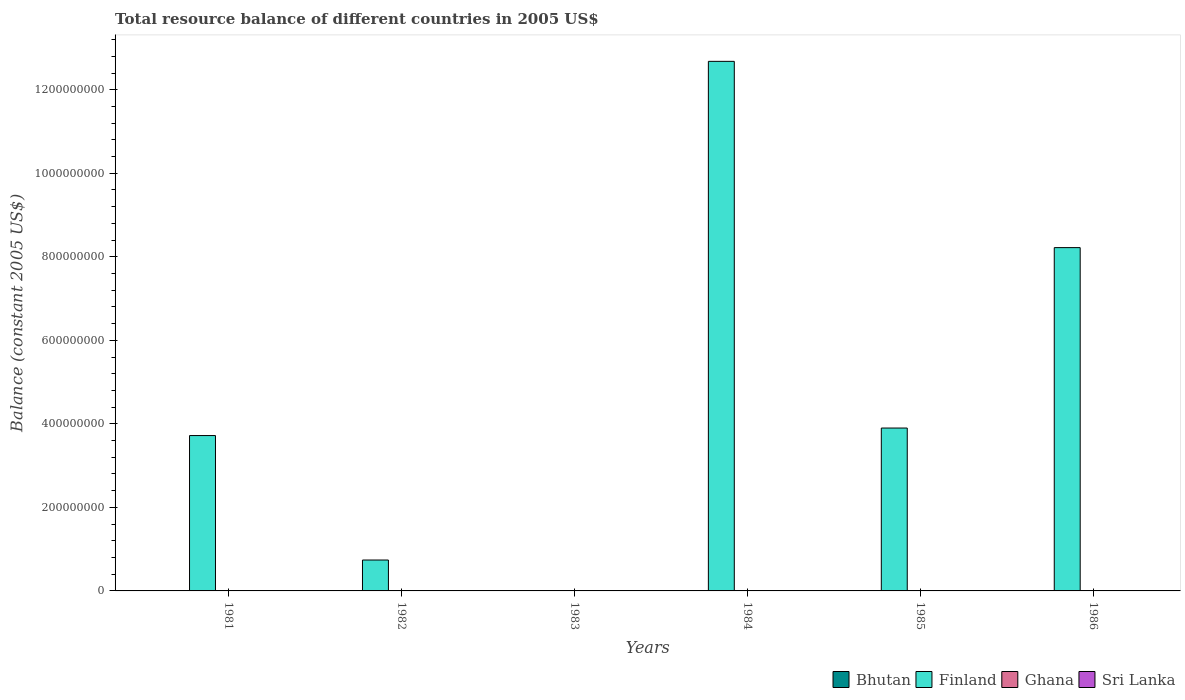Are the number of bars per tick equal to the number of legend labels?
Your response must be concise. No. Are the number of bars on each tick of the X-axis equal?
Make the answer very short. No. How many bars are there on the 4th tick from the right?
Make the answer very short. 0. In how many cases, is the number of bars for a given year not equal to the number of legend labels?
Provide a succinct answer. 6. Across all years, what is the maximum total resource balance in Finland?
Offer a terse response. 1.27e+09. Across all years, what is the minimum total resource balance in Ghana?
Offer a very short reply. 0. What is the total total resource balance in Sri Lanka in the graph?
Provide a succinct answer. 0. What is the difference between the total resource balance in Finland in 1982 and the total resource balance in Bhutan in 1985?
Offer a very short reply. 7.40e+07. What is the average total resource balance in Ghana per year?
Offer a very short reply. 5133.33. In the year 1982, what is the difference between the total resource balance in Ghana and total resource balance in Finland?
Provide a short and direct response. -7.40e+07. What is the difference between the highest and the second highest total resource balance in Finland?
Provide a short and direct response. 4.46e+08. What is the difference between the highest and the lowest total resource balance in Finland?
Offer a very short reply. 1.27e+09. Is it the case that in every year, the sum of the total resource balance in Bhutan and total resource balance in Finland is greater than the sum of total resource balance in Sri Lanka and total resource balance in Ghana?
Your answer should be very brief. No. Is it the case that in every year, the sum of the total resource balance in Finland and total resource balance in Ghana is greater than the total resource balance in Bhutan?
Provide a succinct answer. No. How many bars are there?
Give a very brief answer. 6. Are all the bars in the graph horizontal?
Provide a short and direct response. No. Are the values on the major ticks of Y-axis written in scientific E-notation?
Provide a short and direct response. No. Does the graph contain any zero values?
Offer a terse response. Yes. Does the graph contain grids?
Your response must be concise. No. Where does the legend appear in the graph?
Give a very brief answer. Bottom right. How many legend labels are there?
Keep it short and to the point. 4. How are the legend labels stacked?
Provide a short and direct response. Horizontal. What is the title of the graph?
Your answer should be very brief. Total resource balance of different countries in 2005 US$. Does "Gambia, The" appear as one of the legend labels in the graph?
Provide a short and direct response. No. What is the label or title of the X-axis?
Give a very brief answer. Years. What is the label or title of the Y-axis?
Your answer should be compact. Balance (constant 2005 US$). What is the Balance (constant 2005 US$) in Finland in 1981?
Your answer should be very brief. 3.72e+08. What is the Balance (constant 2005 US$) of Bhutan in 1982?
Offer a terse response. 0. What is the Balance (constant 2005 US$) of Finland in 1982?
Provide a succinct answer. 7.40e+07. What is the Balance (constant 2005 US$) in Ghana in 1982?
Ensure brevity in your answer.  3.08e+04. What is the Balance (constant 2005 US$) in Sri Lanka in 1982?
Make the answer very short. 0. What is the Balance (constant 2005 US$) of Bhutan in 1983?
Your answer should be very brief. 0. What is the Balance (constant 2005 US$) of Sri Lanka in 1983?
Ensure brevity in your answer.  0. What is the Balance (constant 2005 US$) in Finland in 1984?
Your answer should be compact. 1.27e+09. What is the Balance (constant 2005 US$) in Sri Lanka in 1984?
Your answer should be compact. 0. What is the Balance (constant 2005 US$) of Finland in 1985?
Provide a short and direct response. 3.90e+08. What is the Balance (constant 2005 US$) in Ghana in 1985?
Your answer should be very brief. 0. What is the Balance (constant 2005 US$) in Sri Lanka in 1985?
Give a very brief answer. 0. What is the Balance (constant 2005 US$) of Finland in 1986?
Keep it short and to the point. 8.22e+08. Across all years, what is the maximum Balance (constant 2005 US$) in Finland?
Provide a succinct answer. 1.27e+09. Across all years, what is the maximum Balance (constant 2005 US$) of Ghana?
Keep it short and to the point. 3.08e+04. What is the total Balance (constant 2005 US$) in Finland in the graph?
Your response must be concise. 2.93e+09. What is the total Balance (constant 2005 US$) of Ghana in the graph?
Provide a short and direct response. 3.08e+04. What is the difference between the Balance (constant 2005 US$) in Finland in 1981 and that in 1982?
Give a very brief answer. 2.98e+08. What is the difference between the Balance (constant 2005 US$) in Finland in 1981 and that in 1984?
Keep it short and to the point. -8.96e+08. What is the difference between the Balance (constant 2005 US$) in Finland in 1981 and that in 1985?
Ensure brevity in your answer.  -1.80e+07. What is the difference between the Balance (constant 2005 US$) in Finland in 1981 and that in 1986?
Your answer should be compact. -4.50e+08. What is the difference between the Balance (constant 2005 US$) of Finland in 1982 and that in 1984?
Your answer should be very brief. -1.19e+09. What is the difference between the Balance (constant 2005 US$) of Finland in 1982 and that in 1985?
Your answer should be compact. -3.16e+08. What is the difference between the Balance (constant 2005 US$) in Finland in 1982 and that in 1986?
Your response must be concise. -7.48e+08. What is the difference between the Balance (constant 2005 US$) of Finland in 1984 and that in 1985?
Your answer should be very brief. 8.78e+08. What is the difference between the Balance (constant 2005 US$) in Finland in 1984 and that in 1986?
Make the answer very short. 4.46e+08. What is the difference between the Balance (constant 2005 US$) in Finland in 1985 and that in 1986?
Your answer should be compact. -4.32e+08. What is the difference between the Balance (constant 2005 US$) of Finland in 1981 and the Balance (constant 2005 US$) of Ghana in 1982?
Give a very brief answer. 3.72e+08. What is the average Balance (constant 2005 US$) in Bhutan per year?
Provide a succinct answer. 0. What is the average Balance (constant 2005 US$) of Finland per year?
Ensure brevity in your answer.  4.88e+08. What is the average Balance (constant 2005 US$) of Ghana per year?
Provide a short and direct response. 5133.33. What is the average Balance (constant 2005 US$) in Sri Lanka per year?
Provide a succinct answer. 0. In the year 1982, what is the difference between the Balance (constant 2005 US$) of Finland and Balance (constant 2005 US$) of Ghana?
Provide a short and direct response. 7.40e+07. What is the ratio of the Balance (constant 2005 US$) of Finland in 1981 to that in 1982?
Keep it short and to the point. 5.03. What is the ratio of the Balance (constant 2005 US$) of Finland in 1981 to that in 1984?
Provide a succinct answer. 0.29. What is the ratio of the Balance (constant 2005 US$) of Finland in 1981 to that in 1985?
Make the answer very short. 0.95. What is the ratio of the Balance (constant 2005 US$) in Finland in 1981 to that in 1986?
Offer a terse response. 0.45. What is the ratio of the Balance (constant 2005 US$) in Finland in 1982 to that in 1984?
Your response must be concise. 0.06. What is the ratio of the Balance (constant 2005 US$) of Finland in 1982 to that in 1985?
Give a very brief answer. 0.19. What is the ratio of the Balance (constant 2005 US$) of Finland in 1982 to that in 1986?
Offer a terse response. 0.09. What is the ratio of the Balance (constant 2005 US$) in Finland in 1984 to that in 1985?
Ensure brevity in your answer.  3.25. What is the ratio of the Balance (constant 2005 US$) in Finland in 1984 to that in 1986?
Offer a terse response. 1.54. What is the ratio of the Balance (constant 2005 US$) in Finland in 1985 to that in 1986?
Your answer should be compact. 0.47. What is the difference between the highest and the second highest Balance (constant 2005 US$) in Finland?
Your answer should be very brief. 4.46e+08. What is the difference between the highest and the lowest Balance (constant 2005 US$) of Finland?
Ensure brevity in your answer.  1.27e+09. What is the difference between the highest and the lowest Balance (constant 2005 US$) in Ghana?
Provide a short and direct response. 3.08e+04. 